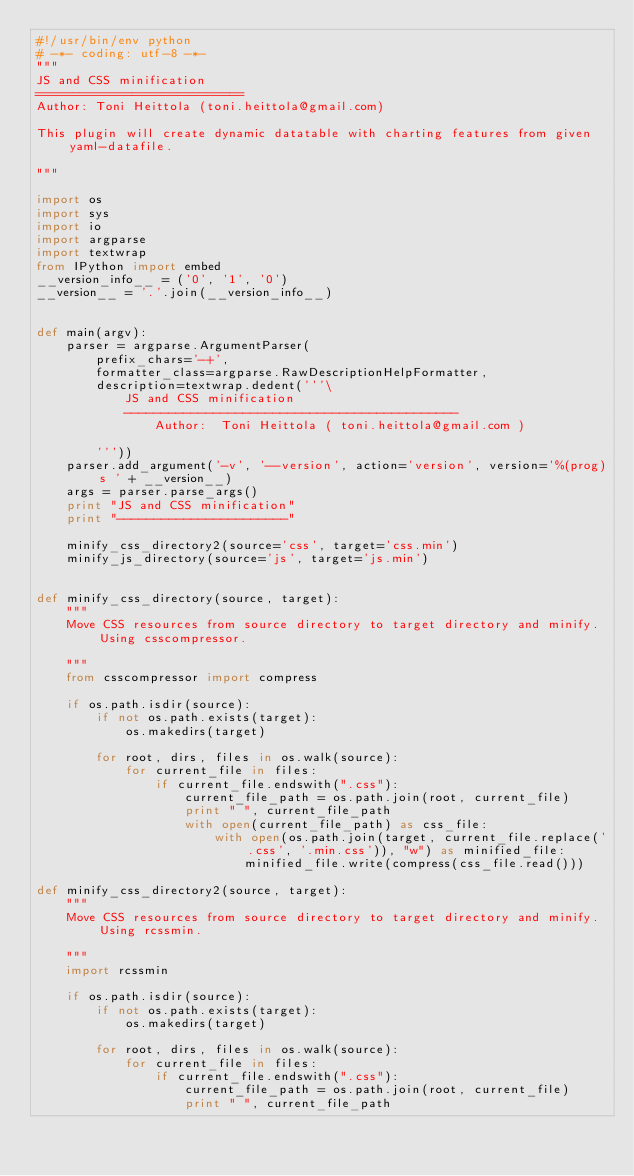Convert code to text. <code><loc_0><loc_0><loc_500><loc_500><_Python_>#!/usr/bin/env python
# -*- coding: utf-8 -*-
"""
JS and CSS minification
============================
Author: Toni Heittola (toni.heittola@gmail.com)

This plugin will create dynamic datatable with charting features from given yaml-datafile.

"""

import os
import sys
import io
import argparse
import textwrap
from IPython import embed
__version_info__ = ('0', '1', '0')
__version__ = '.'.join(__version_info__)


def main(argv):
    parser = argparse.ArgumentParser(
        prefix_chars='-+',
        formatter_class=argparse.RawDescriptionHelpFormatter,
        description=textwrap.dedent('''\
            JS and CSS minification
            ---------------------------------------------
                Author:  Toni Heittola ( toni.heittola@gmail.com )

        '''))
    parser.add_argument('-v', '--version', action='version', version='%(prog)s ' + __version__)
    args = parser.parse_args()
    print "JS and CSS minification"
    print "-----------------------"

    minify_css_directory2(source='css', target='css.min')
    minify_js_directory(source='js', target='js.min')


def minify_css_directory(source, target):
    """
    Move CSS resources from source directory to target directory and minify. Using csscompressor.

    """
    from csscompressor import compress

    if os.path.isdir(source):
        if not os.path.exists(target):
            os.makedirs(target)

        for root, dirs, files in os.walk(source):
            for current_file in files:
                if current_file.endswith(".css"):
                    current_file_path = os.path.join(root, current_file)
                    print " ", current_file_path
                    with open(current_file_path) as css_file:
                        with open(os.path.join(target, current_file.replace('.css', '.min.css')), "w") as minified_file:
                            minified_file.write(compress(css_file.read()))

def minify_css_directory2(source, target):
    """
    Move CSS resources from source directory to target directory and minify. Using rcssmin.

    """
    import rcssmin

    if os.path.isdir(source):
        if not os.path.exists(target):
            os.makedirs(target)

        for root, dirs, files in os.walk(source):
            for current_file in files:
                if current_file.endswith(".css"):
                    current_file_path = os.path.join(root, current_file)
                    print " ", current_file_path</code> 